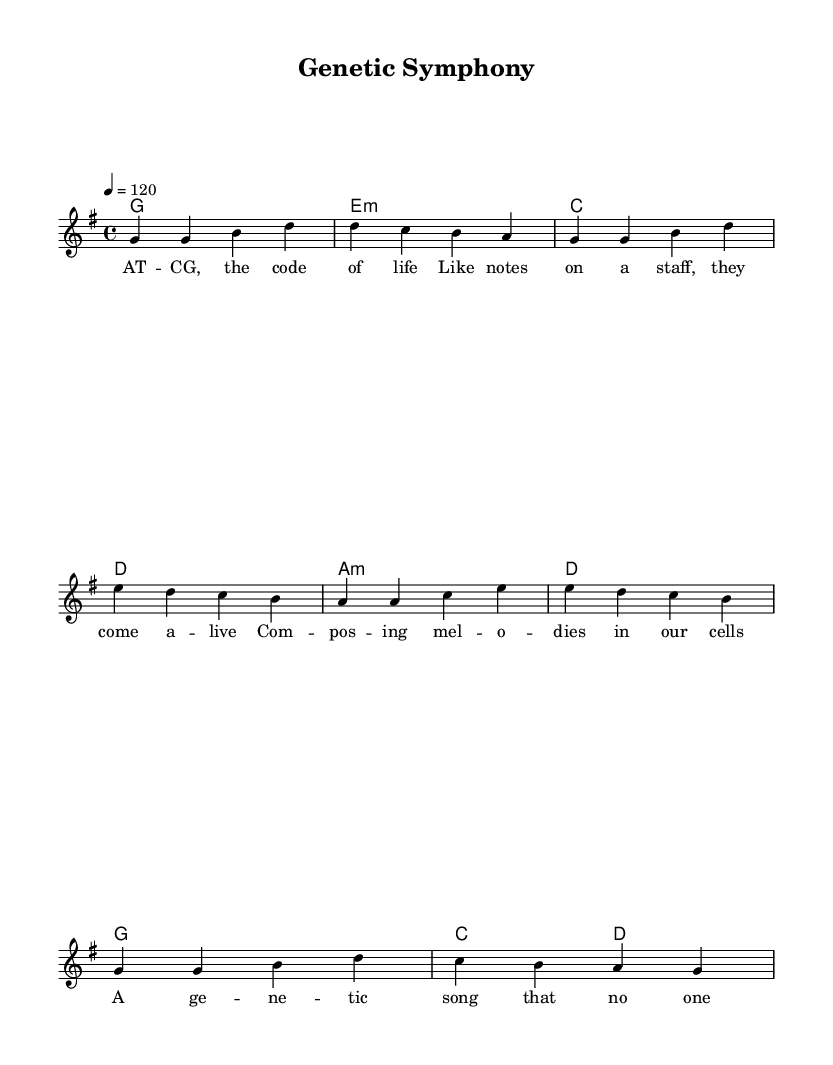What is the key signature of this music? The key signature is G major, which has one sharp (F#). This can be determined from the key indication at the beginning of the score.
Answer: G major What is the time signature of this piece? The time signature is 4/4, indicated at the beginning of the score. This means there are four beats in each measure.
Answer: 4/4 What is the tempo marking for this music? The tempo marking is quarter note equals 120, which specifies the speed at which the piece should be played. This was noted in the score.
Answer: 120 How many measures are there in the melody? By counting the individual measures in the melody line, we can determine the total number. There are eight measures in total.
Answer: 8 Which chord follows the G major chord in the harmonies? The chord that follows the G major chord, based on the chord progression in the score, is an E minor chord. This can be identified by looking at the sequence of chords in the harmony section.
Answer: E minor What metaphor is used in the lyrics to describe DNA? The lyrics metaphorically describe DNA as "the code of life," comparing it to notes that "come alive." This reflects the idea of DNA as a composition like music.
Answer: the code of life How does this piece relate to K-Pop characteristics? This piece incorporates metaphorical lyrics and a catchy melodic structure, which are common features in K-Pop songs. The blend of music and meaningful themes is often found in K-Pop.
Answer: metaphorical lyrics 